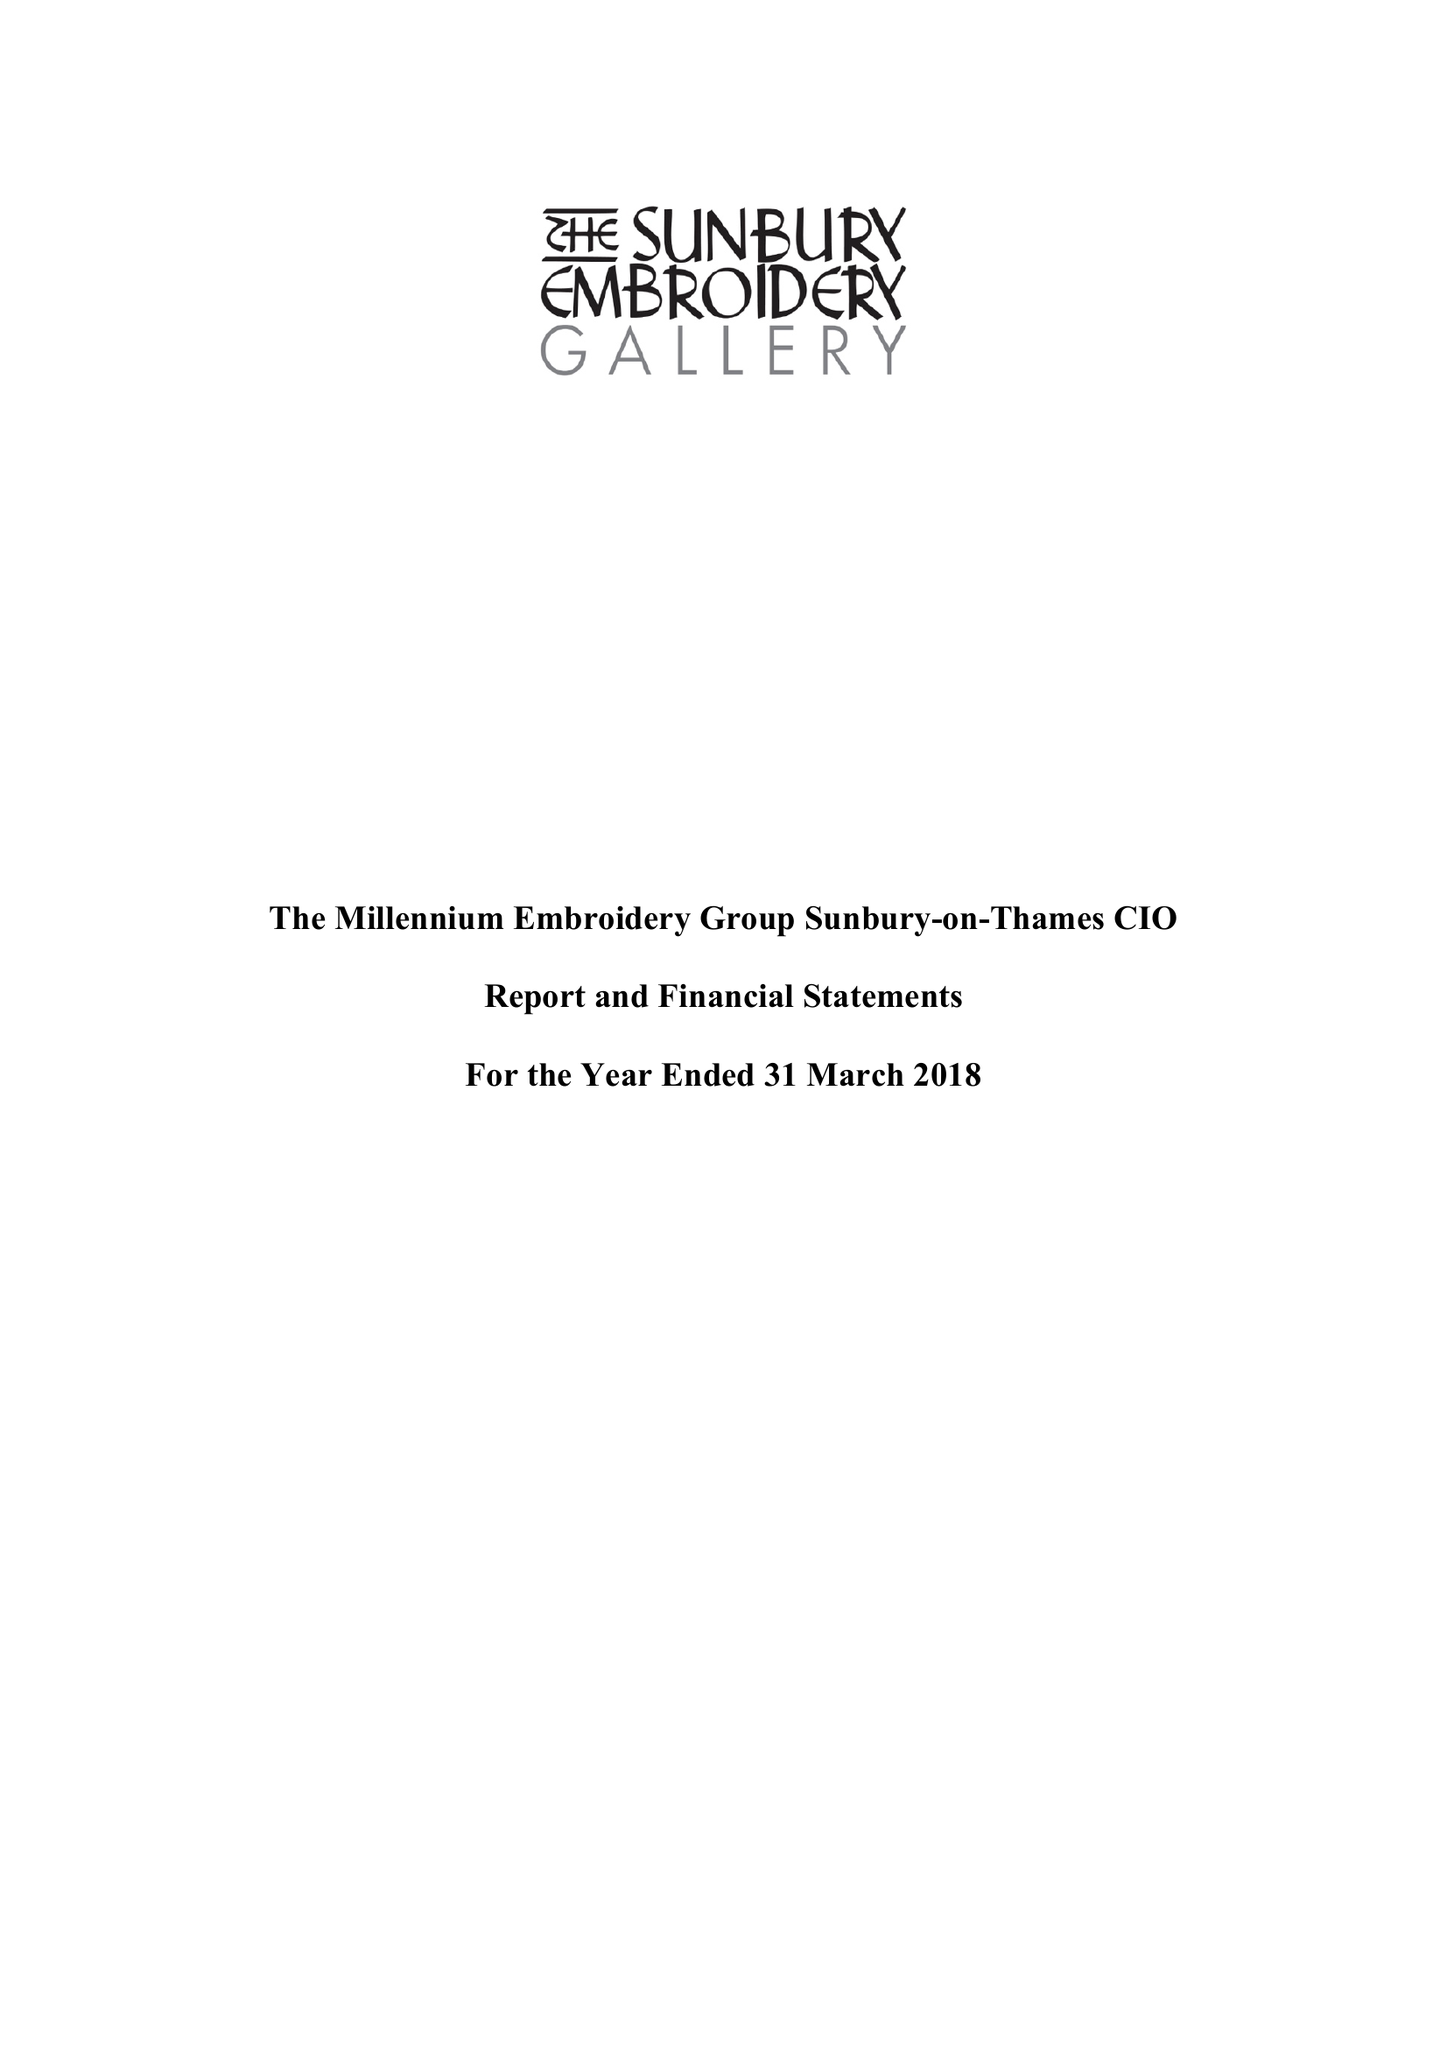What is the value for the spending_annually_in_british_pounds?
Answer the question using a single word or phrase. 170549.00 